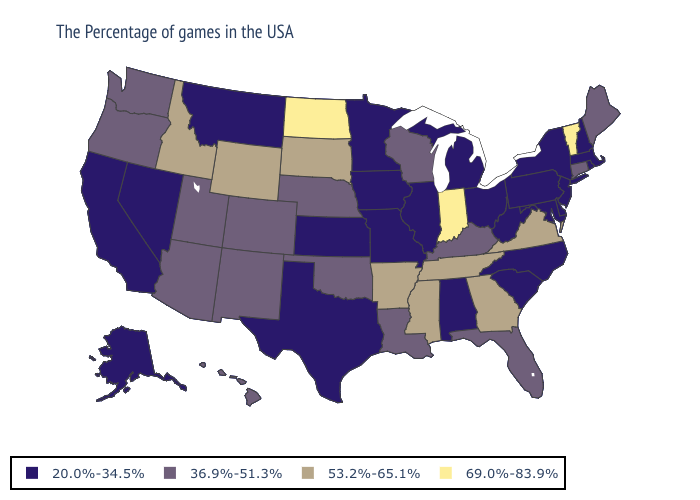Does the first symbol in the legend represent the smallest category?
Keep it brief. Yes. Name the states that have a value in the range 20.0%-34.5%?
Answer briefly. Massachusetts, Rhode Island, New Hampshire, New York, New Jersey, Delaware, Maryland, Pennsylvania, North Carolina, South Carolina, West Virginia, Ohio, Michigan, Alabama, Illinois, Missouri, Minnesota, Iowa, Kansas, Texas, Montana, Nevada, California, Alaska. Does Tennessee have the highest value in the USA?
Quick response, please. No. Name the states that have a value in the range 36.9%-51.3%?
Give a very brief answer. Maine, Connecticut, Florida, Kentucky, Wisconsin, Louisiana, Nebraska, Oklahoma, Colorado, New Mexico, Utah, Arizona, Washington, Oregon, Hawaii. Does New Hampshire have the same value as Maine?
Short answer required. No. Does New Jersey have the highest value in the USA?
Answer briefly. No. Does Hawaii have a lower value than Virginia?
Write a very short answer. Yes. Does Maryland have the highest value in the USA?
Short answer required. No. Among the states that border Louisiana , does Arkansas have the highest value?
Short answer required. Yes. Which states have the highest value in the USA?
Quick response, please. Vermont, Indiana, North Dakota. What is the highest value in the USA?
Be succinct. 69.0%-83.9%. Name the states that have a value in the range 36.9%-51.3%?
Quick response, please. Maine, Connecticut, Florida, Kentucky, Wisconsin, Louisiana, Nebraska, Oklahoma, Colorado, New Mexico, Utah, Arizona, Washington, Oregon, Hawaii. What is the value of Rhode Island?
Short answer required. 20.0%-34.5%. What is the lowest value in the USA?
Short answer required. 20.0%-34.5%. Does Alaska have the lowest value in the USA?
Give a very brief answer. Yes. 